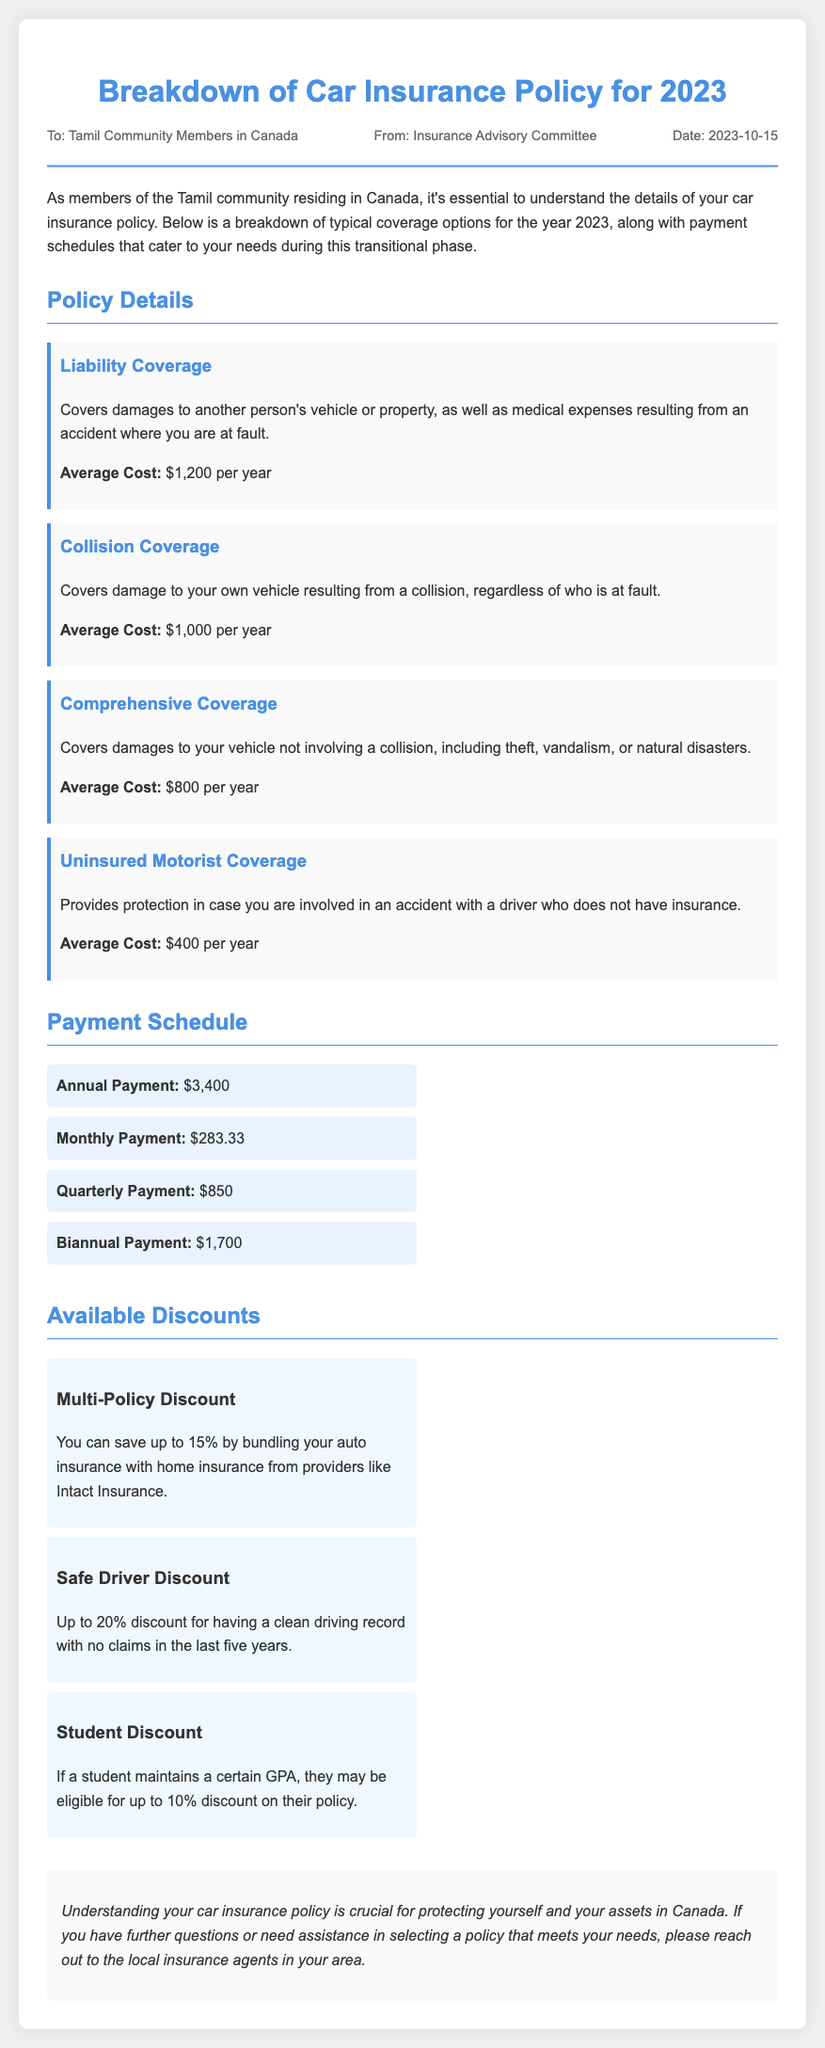What is the average cost of Liability Coverage? The average cost is specifically mentioned for Liability Coverage, which is $1,200 per year.
Answer: $1,200 What is the total annual payment for the car insurance policy? The total annual payment can be found in the Payment Schedule section as $3,400.
Answer: $3,400 What type of discount is offered for having a clean driving record? The document indicates a Safe Driver Discount for a clean driving record with no claims in the last five years.
Answer: Safe Driver Discount How much can be saved through a Multi-Policy Discount? The document states that a Multi-Policy Discount allows saving up to 15% by bundling with home insurance.
Answer: 15% What is the coverage type that protects against uninsured drivers? The specific coverage type that protects against uninsured drivers is called Uninsured Motorist Coverage.
Answer: Uninsured Motorist Coverage What is the cost of Comprehensive Coverage per year? The average cost of Comprehensive Coverage is detailed in the document as $800 per year.
Answer: $800 Which section provides the payment options for the insurance policy? The section that outlines the payment options is titled Payment Schedule.
Answer: Payment Schedule How much is the discount available for students maintaining a certain GPA? The document specifies that a student may be eligible for up to a 10% discount if they meet certain GPA criteria.
Answer: 10% 